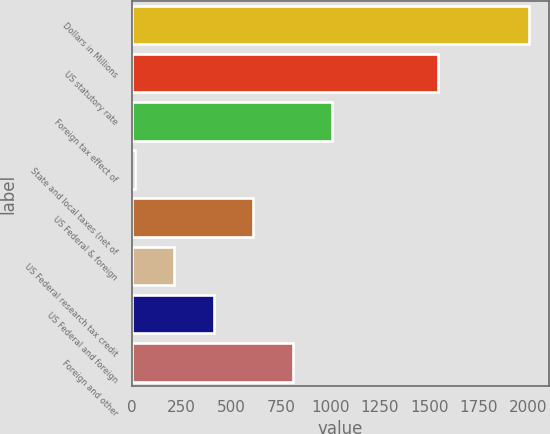<chart> <loc_0><loc_0><loc_500><loc_500><bar_chart><fcel>Dollars in Millions<fcel>US statutory rate<fcel>Foreign tax effect of<fcel>State and local taxes (net of<fcel>US Federal & foreign<fcel>US Federal research tax credit<fcel>US Federal and foreign<fcel>Foreign and other<nl><fcel>2004<fcel>1546<fcel>1009<fcel>14<fcel>611<fcel>213<fcel>412<fcel>810<nl></chart> 